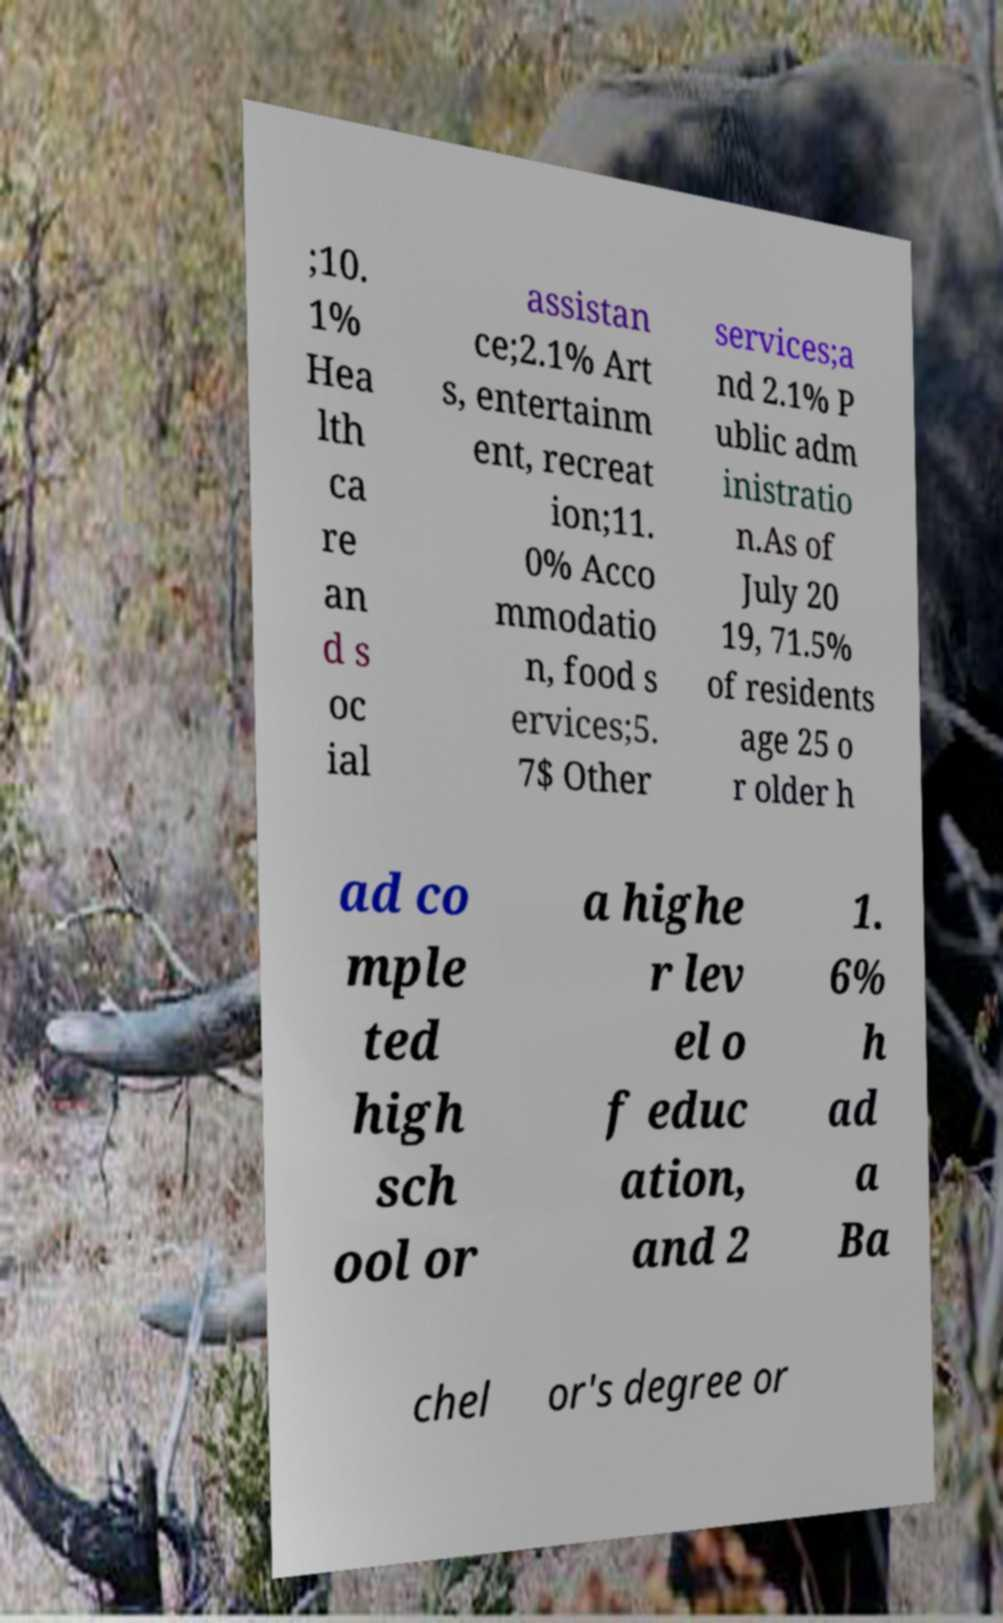For documentation purposes, I need the text within this image transcribed. Could you provide that? ;10. 1% Hea lth ca re an d s oc ial assistan ce;2.1% Art s, entertainm ent, recreat ion;11. 0% Acco mmodatio n, food s ervices;5. 7$ Other services;a nd 2.1% P ublic adm inistratio n.As of July 20 19, 71.5% of residents age 25 o r older h ad co mple ted high sch ool or a highe r lev el o f educ ation, and 2 1. 6% h ad a Ba chel or's degree or 